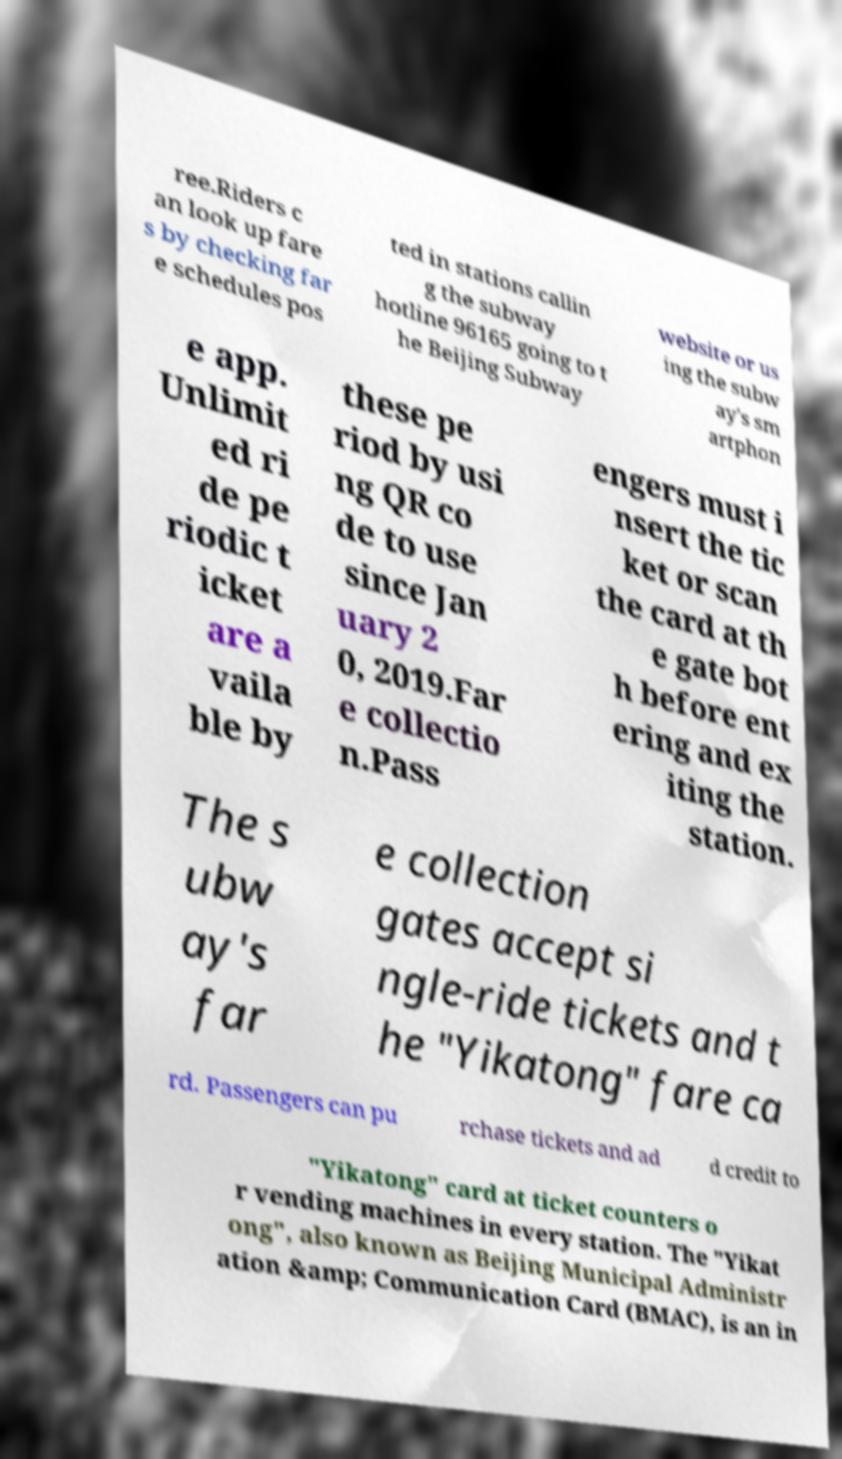Could you extract and type out the text from this image? ree.Riders c an look up fare s by checking far e schedules pos ted in stations callin g the subway hotline 96165 going to t he Beijing Subway website or us ing the subw ay's sm artphon e app. Unlimit ed ri de pe riodic t icket are a vaila ble by these pe riod by usi ng QR co de to use since Jan uary 2 0, 2019.Far e collectio n.Pass engers must i nsert the tic ket or scan the card at th e gate bot h before ent ering and ex iting the station. The s ubw ay's far e collection gates accept si ngle-ride tickets and t he "Yikatong" fare ca rd. Passengers can pu rchase tickets and ad d credit to "Yikatong" card at ticket counters o r vending machines in every station. The "Yikat ong", also known as Beijing Municipal Administr ation &amp; Communication Card (BMAC), is an in 